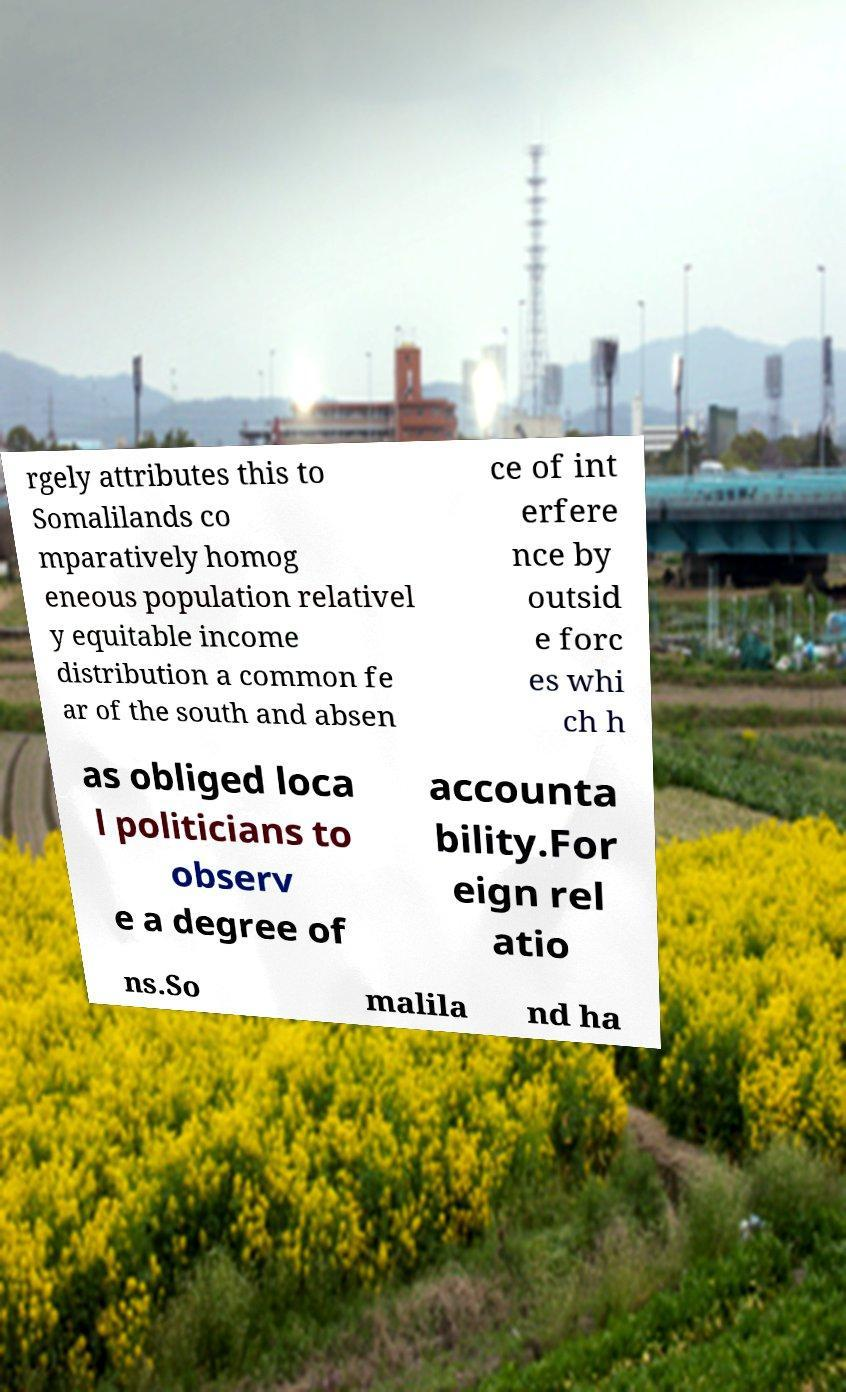Can you accurately transcribe the text from the provided image for me? rgely attributes this to Somalilands co mparatively homog eneous population relativel y equitable income distribution a common fe ar of the south and absen ce of int erfere nce by outsid e forc es whi ch h as obliged loca l politicians to observ e a degree of accounta bility.For eign rel atio ns.So malila nd ha 